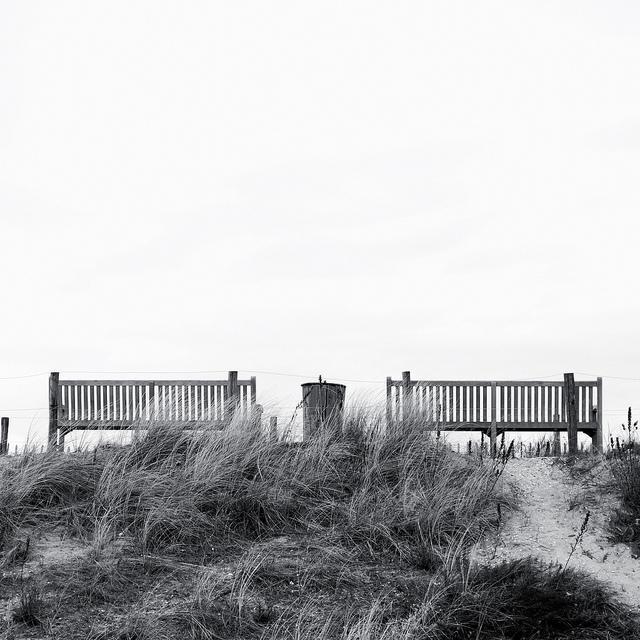How many benches are there?
Give a very brief answer. 2. How many men have red shirts?
Give a very brief answer. 0. 